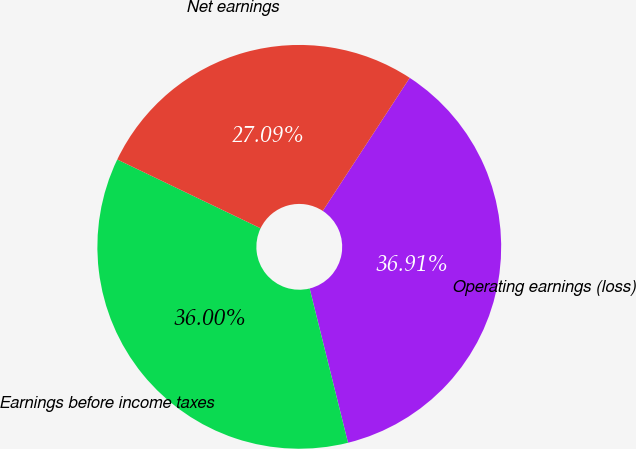Convert chart. <chart><loc_0><loc_0><loc_500><loc_500><pie_chart><fcel>Operating earnings (loss)<fcel>Earnings before income taxes<fcel>Net earnings<nl><fcel>36.91%<fcel>36.0%<fcel>27.09%<nl></chart> 